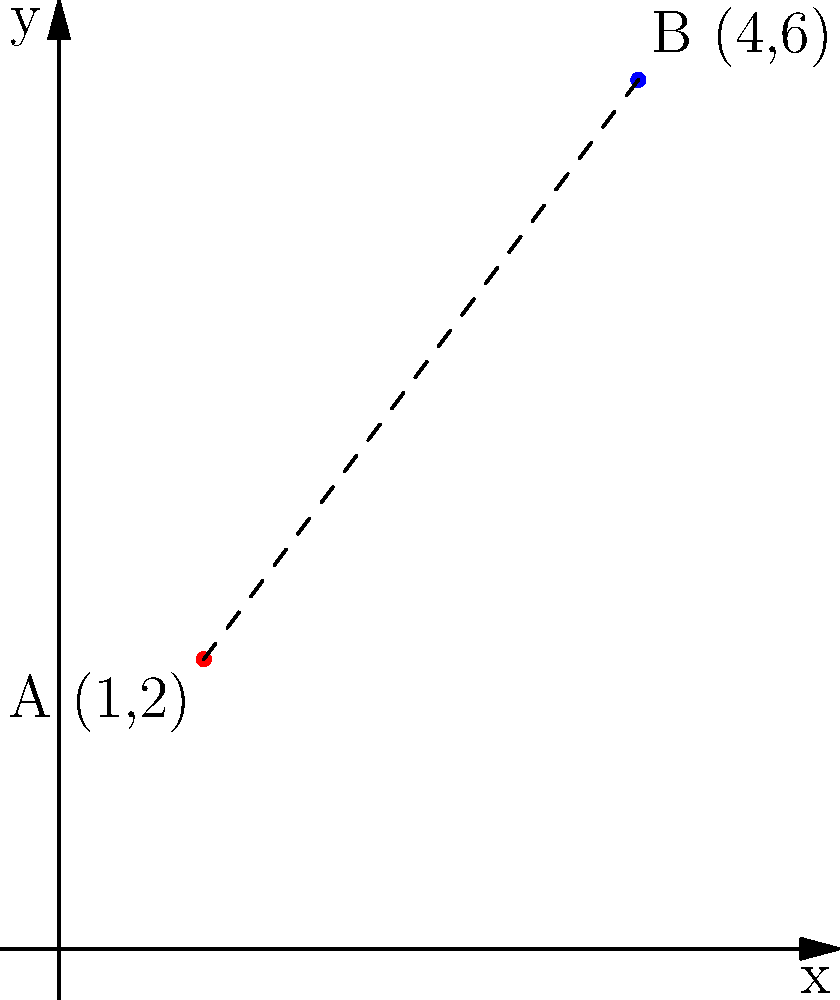As a dog trainer, you have two training locations marked on a coordinate plane. Location A is at (1,2) and Location B is at (4,6). What is the straight-line distance between these two training locations? To find the distance between two points on a coordinate plane, we can use the distance formula, which is derived from the Pythagorean theorem:

$$d = \sqrt{(x_2 - x_1)^2 + (y_2 - y_1)^2}$$

Where $(x_1, y_1)$ are the coordinates of the first point and $(x_2, y_2)$ are the coordinates of the second point.

Let's plug in our values:
Point A: $(x_1, y_1) = (1, 2)$
Point B: $(x_2, y_2) = (4, 6)$

Now, let's calculate:

1) $d = \sqrt{(4 - 1)^2 + (6 - 2)^2}$

2) $d = \sqrt{3^2 + 4^2}$

3) $d = \sqrt{9 + 16}$

4) $d = \sqrt{25}$

5) $d = 5$

Therefore, the straight-line distance between the two training locations is 5 units.
Answer: 5 units 